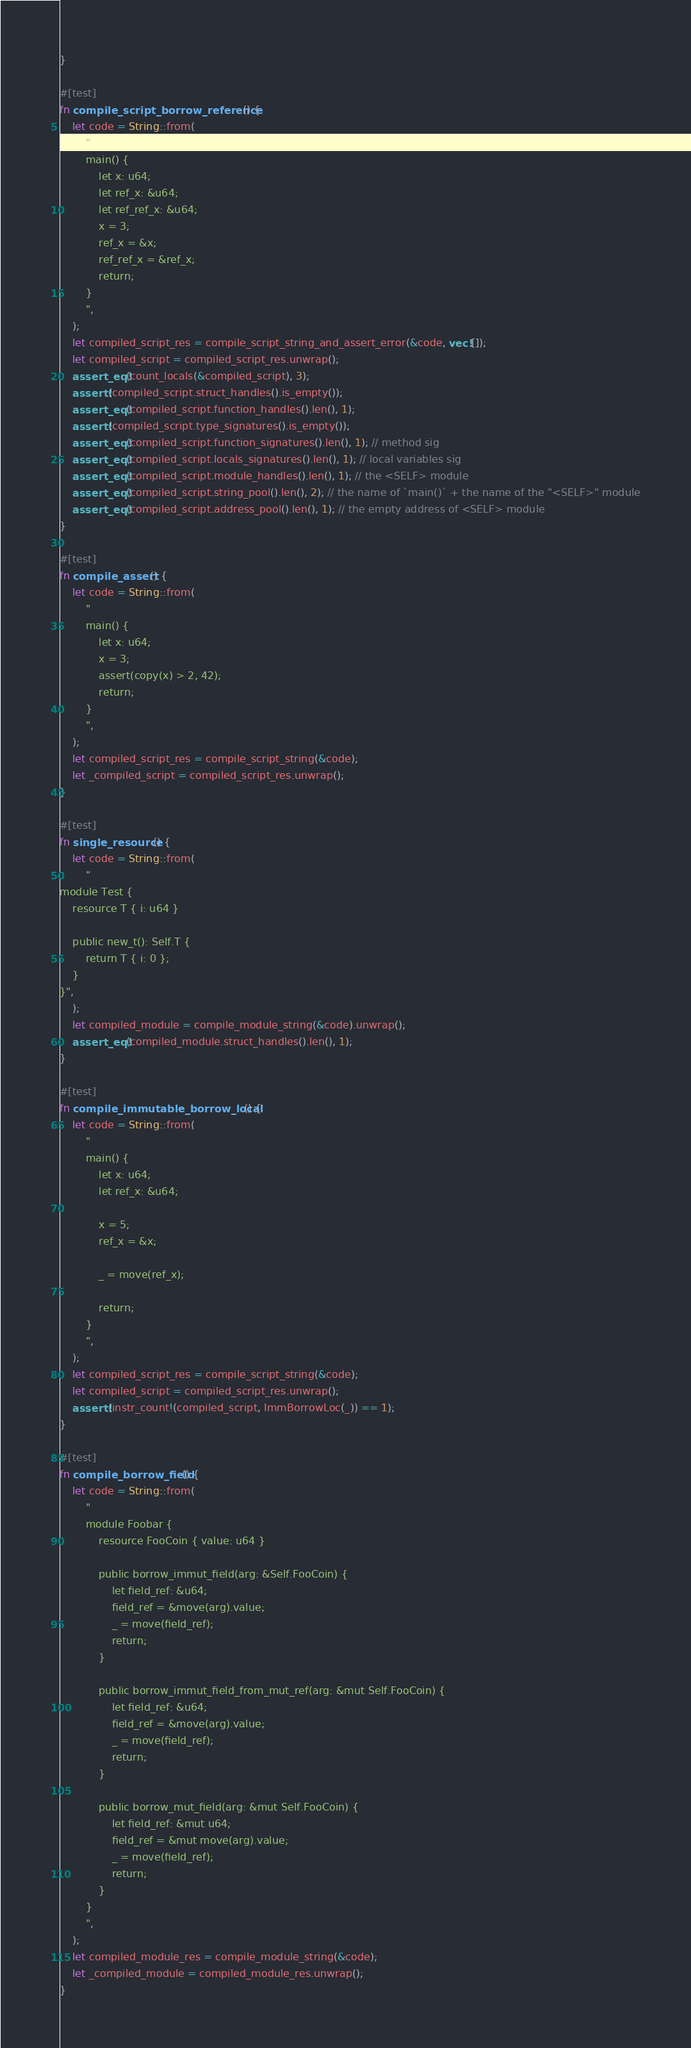<code> <loc_0><loc_0><loc_500><loc_500><_Rust_>}

#[test]
fn compile_script_borrow_reference() {
    let code = String::from(
        "
        main() {
            let x: u64;
            let ref_x: &u64;
            let ref_ref_x: &u64;
            x = 3;
            ref_x = &x;
            ref_ref_x = &ref_x;
            return;
        }
        ",
    );
    let compiled_script_res = compile_script_string_and_assert_error(&code, vec![]);
    let compiled_script = compiled_script_res.unwrap();
    assert_eq!(count_locals(&compiled_script), 3);
    assert!(compiled_script.struct_handles().is_empty());
    assert_eq!(compiled_script.function_handles().len(), 1);
    assert!(compiled_script.type_signatures().is_empty());
    assert_eq!(compiled_script.function_signatures().len(), 1); // method sig
    assert_eq!(compiled_script.locals_signatures().len(), 1); // local variables sig
    assert_eq!(compiled_script.module_handles().len(), 1); // the <SELF> module
    assert_eq!(compiled_script.string_pool().len(), 2); // the name of `main()` + the name of the "<SELF>" module
    assert_eq!(compiled_script.address_pool().len(), 1); // the empty address of <SELF> module
}

#[test]
fn compile_assert() {
    let code = String::from(
        "
        main() {
            let x: u64;
            x = 3;
            assert(copy(x) > 2, 42);
            return;
        }
        ",
    );
    let compiled_script_res = compile_script_string(&code);
    let _compiled_script = compiled_script_res.unwrap();
}

#[test]
fn single_resource() {
    let code = String::from(
        "
module Test {
    resource T { i: u64 }

    public new_t(): Self.T {
        return T { i: 0 };
    }
}",
    );
    let compiled_module = compile_module_string(&code).unwrap();
    assert_eq!(compiled_module.struct_handles().len(), 1);
}

#[test]
fn compile_immutable_borrow_local() {
    let code = String::from(
        "
        main() {
            let x: u64;
            let ref_x: &u64;

            x = 5;
            ref_x = &x;

            _ = move(ref_x);

            return;
        }
        ",
    );
    let compiled_script_res = compile_script_string(&code);
    let compiled_script = compiled_script_res.unwrap();
    assert!(instr_count!(compiled_script, ImmBorrowLoc(_)) == 1);
}

#[test]
fn compile_borrow_field() {
    let code = String::from(
        "
        module Foobar {
            resource FooCoin { value: u64 }

            public borrow_immut_field(arg: &Self.FooCoin) {
                let field_ref: &u64;
                field_ref = &move(arg).value;
                _ = move(field_ref);
                return;
            }

            public borrow_immut_field_from_mut_ref(arg: &mut Self.FooCoin) {
                let field_ref: &u64;
                field_ref = &move(arg).value;
                _ = move(field_ref);
                return;
            }

            public borrow_mut_field(arg: &mut Self.FooCoin) {
                let field_ref: &mut u64;
                field_ref = &mut move(arg).value;
                _ = move(field_ref);
                return;
            }
        }
        ",
    );
    let compiled_module_res = compile_module_string(&code);
    let _compiled_module = compiled_module_res.unwrap();
}
</code> 